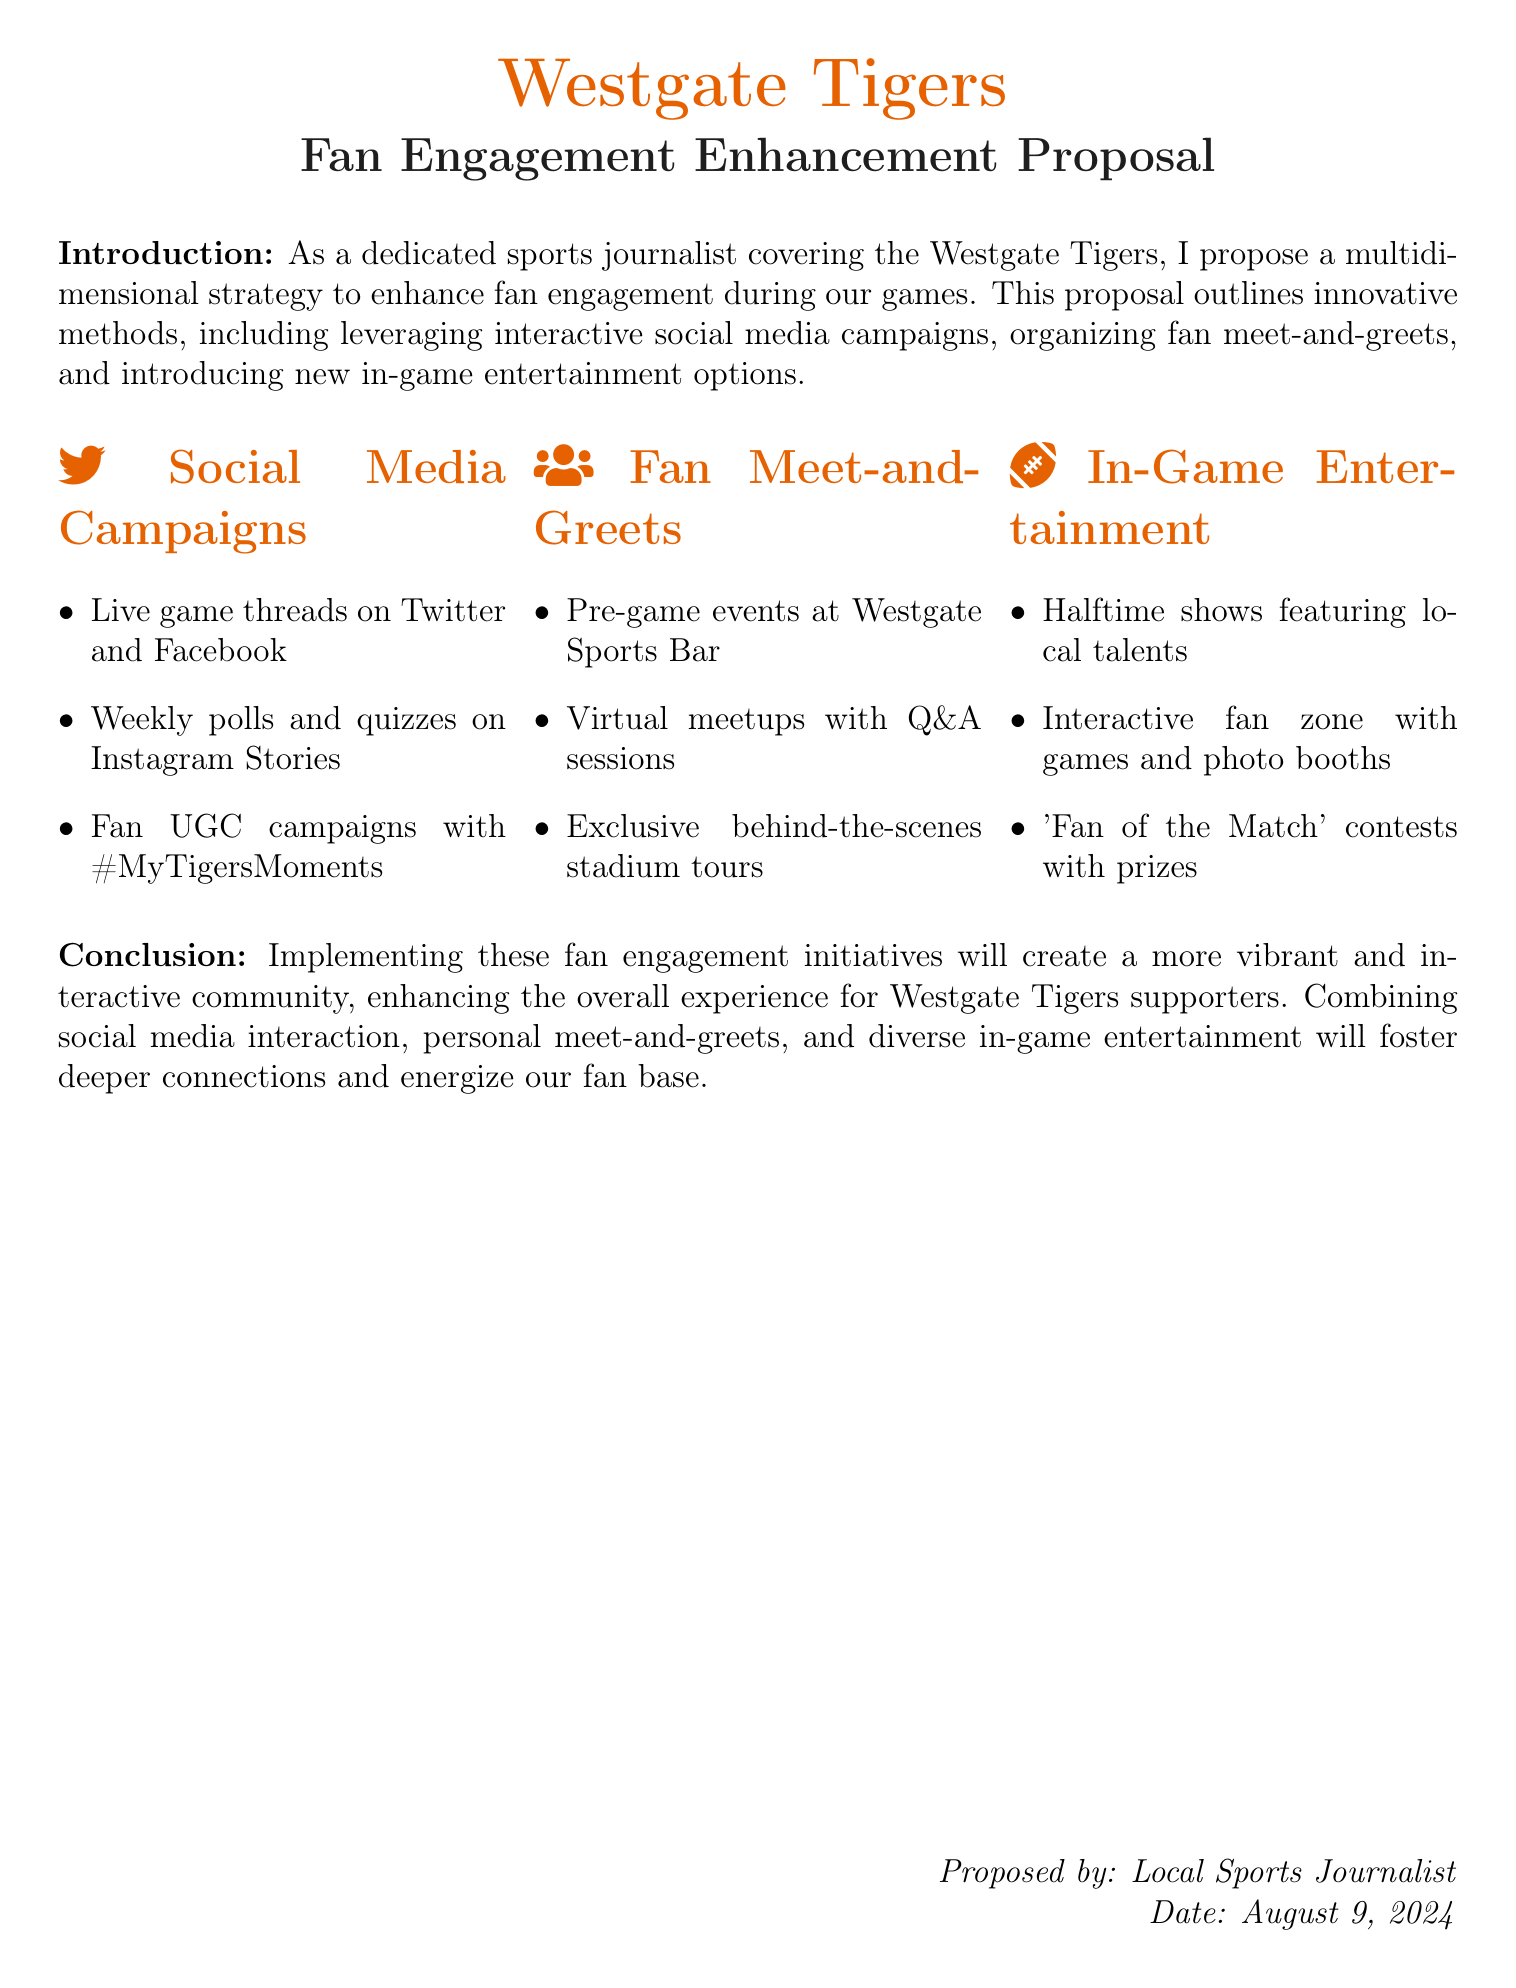What is the title of the proposal? The title is presented in the document under the heading, which is "Fan Engagement Enhancement Proposal".
Answer: Fan Engagement Enhancement Proposal Who proposed the document? The author of the proposal is mentioned at the bottom of the document where it states "Proposed by: Local Sports Journalist".
Answer: Local Sports Journalist What color is specified for the title? The document specifies the color for the title, which is "tigerOrange".
Answer: tigerOrange What interactive campaign is suggested on Instagram? The document includes a specific campaign involving "quizzes on Instagram Stories".
Answer: quizzes on Instagram Stories How many sections are dedicated to fan engagement methods? The proposal outlines three distinct sections related to fan engagement methods.
Answer: 3 What is one of the pre-game fan engagement strategies? The proposal mentions hosting "Pre-game events at Westgate Sports Bar" as a method of fan engagement.
Answer: Pre-game events at Westgate Sports Bar Which contest offers prizes during games? The document identifies the "Fan of the Match" contest as providing prizes to participants during games.
Answer: Fan of the Match What in-game entertainment option involves local talent? The proposal features "Halftime shows featuring local talents" as a form of entertainment during games.
Answer: Halftime shows featuring local talents What type of interaction is planned for social media during games? The proposal suggests implementing "Live game threads on Twitter and Facebook" for real-time engagement.
Answer: Live game threads on Twitter and Facebook 